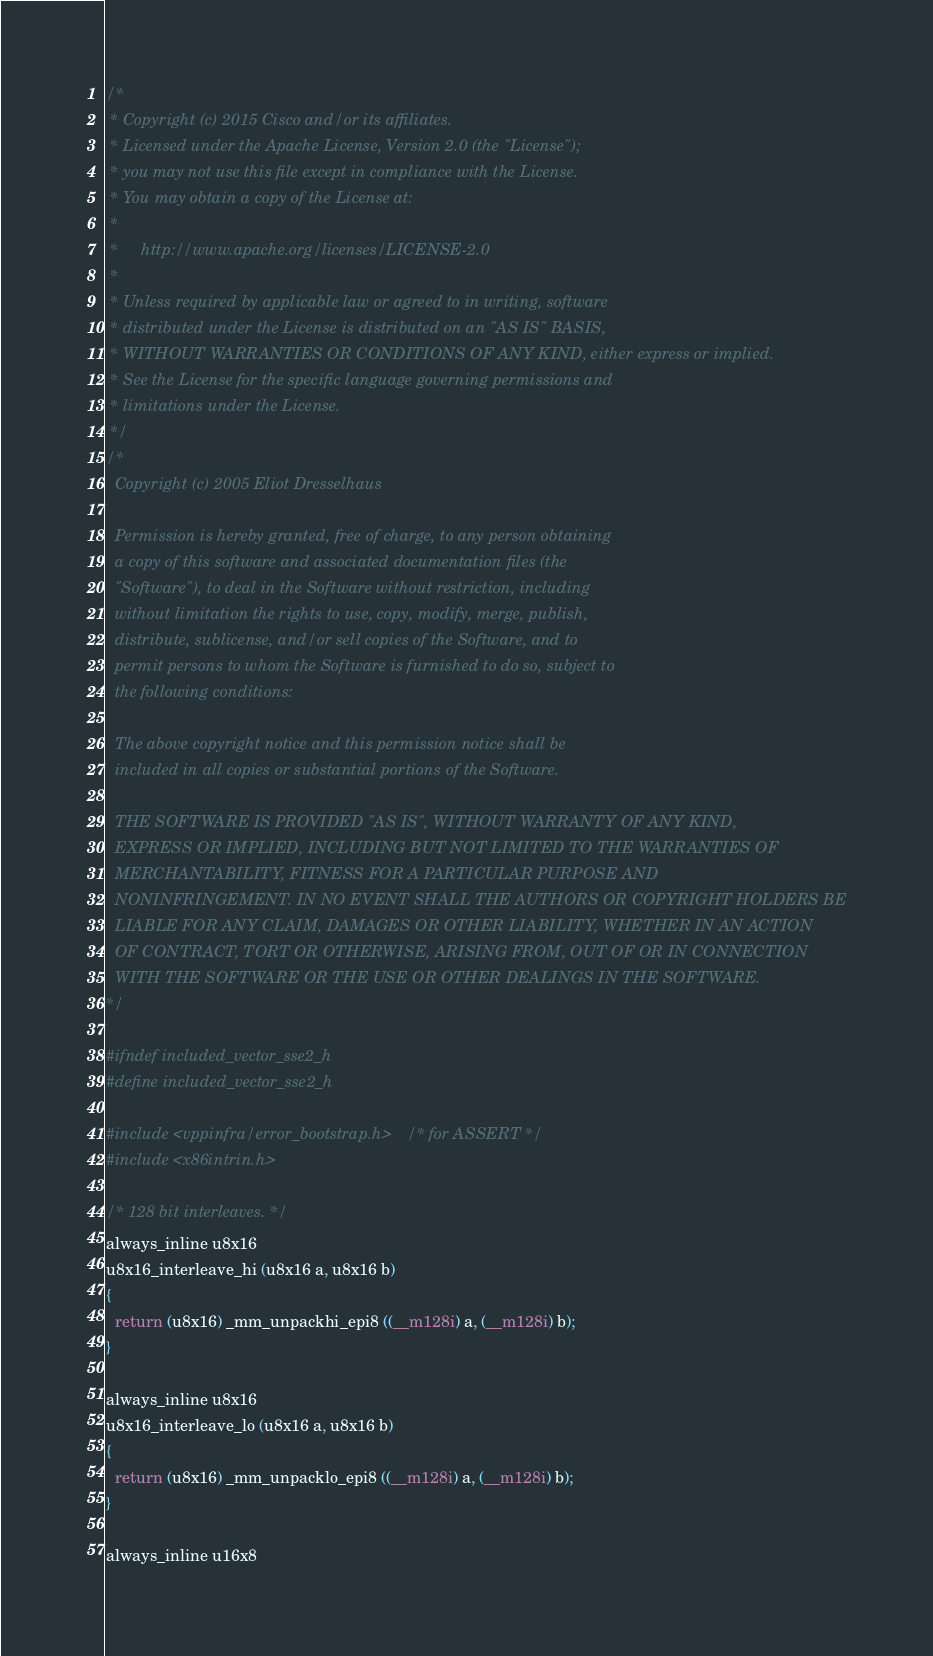<code> <loc_0><loc_0><loc_500><loc_500><_C_>/*
 * Copyright (c) 2015 Cisco and/or its affiliates.
 * Licensed under the Apache License, Version 2.0 (the "License");
 * you may not use this file except in compliance with the License.
 * You may obtain a copy of the License at:
 *
 *     http://www.apache.org/licenses/LICENSE-2.0
 *
 * Unless required by applicable law or agreed to in writing, software
 * distributed under the License is distributed on an "AS IS" BASIS,
 * WITHOUT WARRANTIES OR CONDITIONS OF ANY KIND, either express or implied.
 * See the License for the specific language governing permissions and
 * limitations under the License.
 */
/*
  Copyright (c) 2005 Eliot Dresselhaus

  Permission is hereby granted, free of charge, to any person obtaining
  a copy of this software and associated documentation files (the
  "Software"), to deal in the Software without restriction, including
  without limitation the rights to use, copy, modify, merge, publish,
  distribute, sublicense, and/or sell copies of the Software, and to
  permit persons to whom the Software is furnished to do so, subject to
  the following conditions:

  The above copyright notice and this permission notice shall be
  included in all copies or substantial portions of the Software.

  THE SOFTWARE IS PROVIDED "AS IS", WITHOUT WARRANTY OF ANY KIND,
  EXPRESS OR IMPLIED, INCLUDING BUT NOT LIMITED TO THE WARRANTIES OF
  MERCHANTABILITY, FITNESS FOR A PARTICULAR PURPOSE AND
  NONINFRINGEMENT. IN NO EVENT SHALL THE AUTHORS OR COPYRIGHT HOLDERS BE
  LIABLE FOR ANY CLAIM, DAMAGES OR OTHER LIABILITY, WHETHER IN AN ACTION
  OF CONTRACT, TORT OR OTHERWISE, ARISING FROM, OUT OF OR IN CONNECTION
  WITH THE SOFTWARE OR THE USE OR OTHER DEALINGS IN THE SOFTWARE.
*/

#ifndef included_vector_sse2_h
#define included_vector_sse2_h

#include <vppinfra/error_bootstrap.h>	/* for ASSERT */
#include <x86intrin.h>

/* 128 bit interleaves. */
always_inline u8x16
u8x16_interleave_hi (u8x16 a, u8x16 b)
{
  return (u8x16) _mm_unpackhi_epi8 ((__m128i) a, (__m128i) b);
}

always_inline u8x16
u8x16_interleave_lo (u8x16 a, u8x16 b)
{
  return (u8x16) _mm_unpacklo_epi8 ((__m128i) a, (__m128i) b);
}

always_inline u16x8</code> 